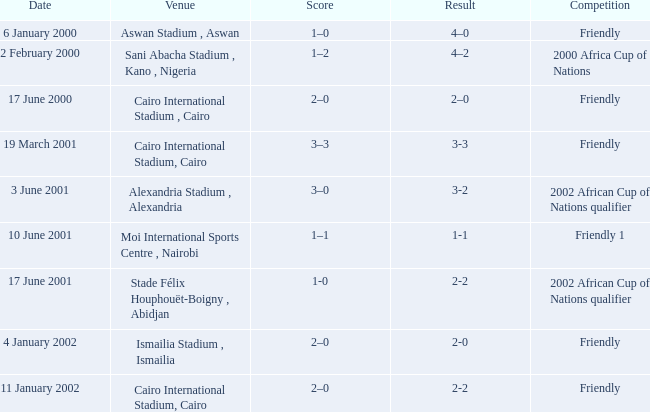What is the outcome of the game that ended with a 3-2 score? 3–0. 